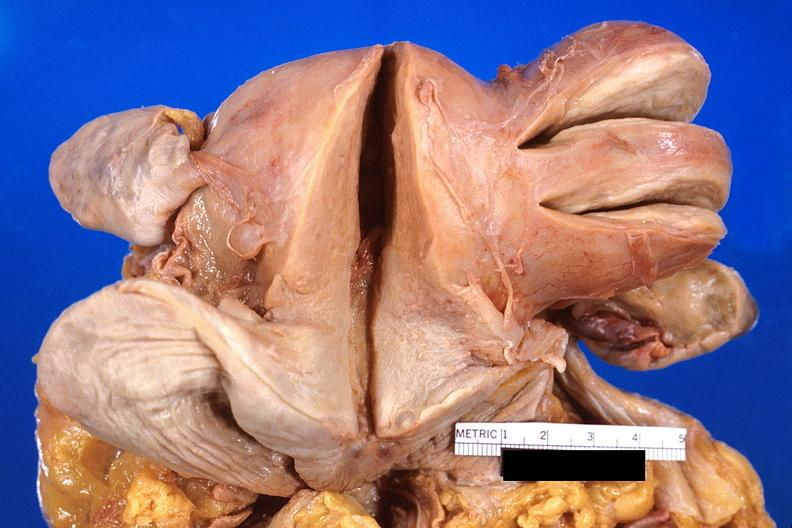where does this part belong to?
Answer the question using a single word or phrase. Female reproductive system 